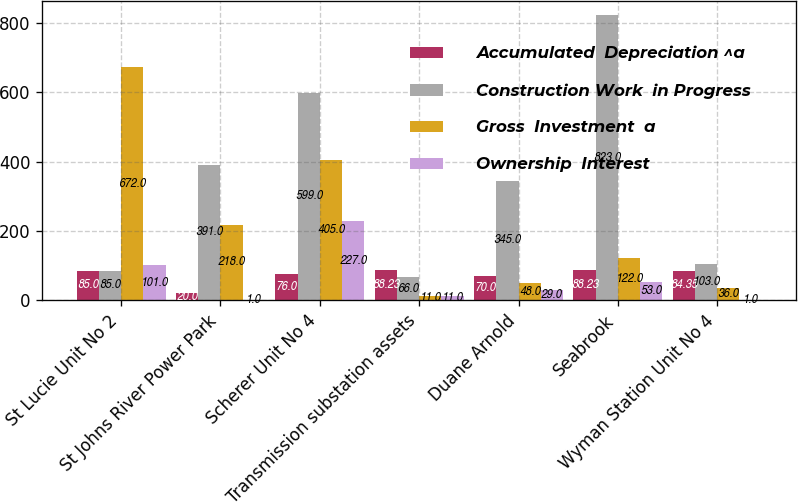<chart> <loc_0><loc_0><loc_500><loc_500><stacked_bar_chart><ecel><fcel>St Lucie Unit No 2<fcel>St Johns River Power Park<fcel>Scherer Unit No 4<fcel>Transmission substation assets<fcel>Duane Arnold<fcel>Seabrook<fcel>Wyman Station Unit No 4<nl><fcel>Accumulated  Depreciation ^a<fcel>85<fcel>20<fcel>76<fcel>88.23<fcel>70<fcel>88.23<fcel>84.35<nl><fcel>Construction Work  in Progress<fcel>85<fcel>391<fcel>599<fcel>66<fcel>345<fcel>823<fcel>103<nl><fcel>Gross  Investment  a<fcel>672<fcel>218<fcel>405<fcel>11<fcel>48<fcel>122<fcel>36<nl><fcel>Ownership  Interest<fcel>101<fcel>1<fcel>227<fcel>11<fcel>29<fcel>53<fcel>1<nl></chart> 